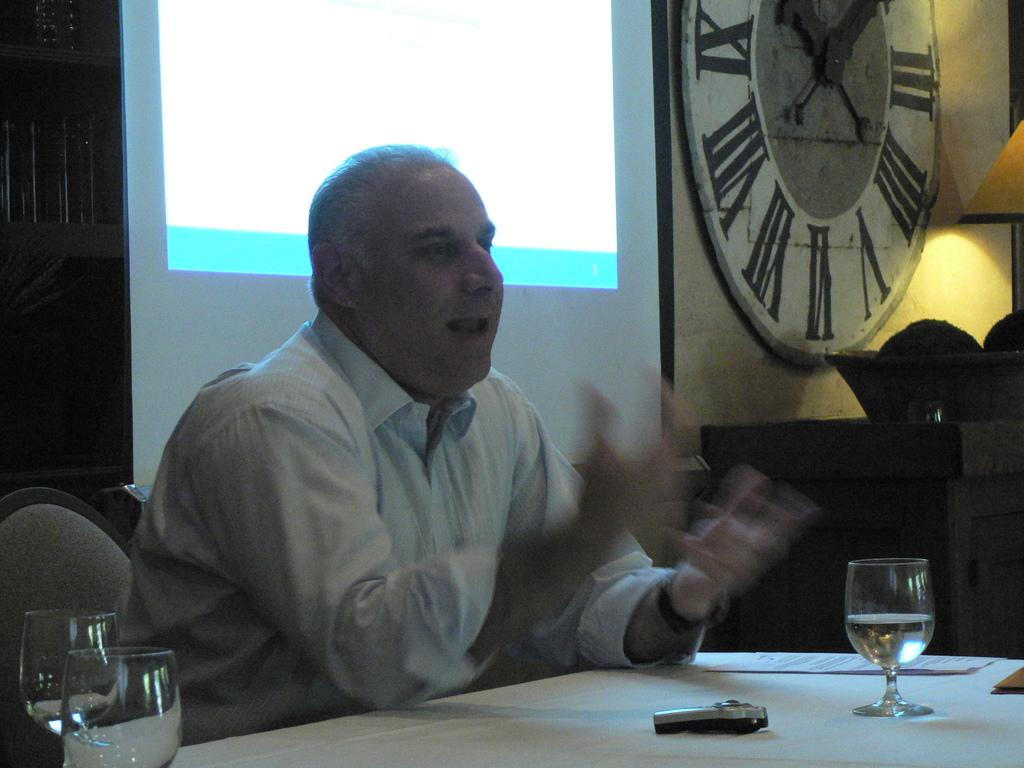Who is present in the image? There is a man in the image. What is the man doing in the image? The man is seated on a chair and speaking. What objects can be seen on the table in the image? There are glasses on the table. What time-related object is present in the room? There is a clock on the wall of the room. What type of lettuce is growing on the edge of the table in the image? There is no lettuce present in the image, nor is there any vegetation growing on the table. 